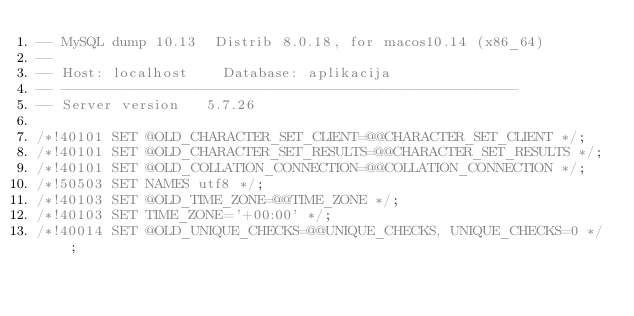Convert code to text. <code><loc_0><loc_0><loc_500><loc_500><_SQL_>-- MySQL dump 10.13  Distrib 8.0.18, for macos10.14 (x86_64)
--
-- Host: localhost    Database: aplikacija
-- ------------------------------------------------------
-- Server version	5.7.26

/*!40101 SET @OLD_CHARACTER_SET_CLIENT=@@CHARACTER_SET_CLIENT */;
/*!40101 SET @OLD_CHARACTER_SET_RESULTS=@@CHARACTER_SET_RESULTS */;
/*!40101 SET @OLD_COLLATION_CONNECTION=@@COLLATION_CONNECTION */;
/*!50503 SET NAMES utf8 */;
/*!40103 SET @OLD_TIME_ZONE=@@TIME_ZONE */;
/*!40103 SET TIME_ZONE='+00:00' */;
/*!40014 SET @OLD_UNIQUE_CHECKS=@@UNIQUE_CHECKS, UNIQUE_CHECKS=0 */;</code> 